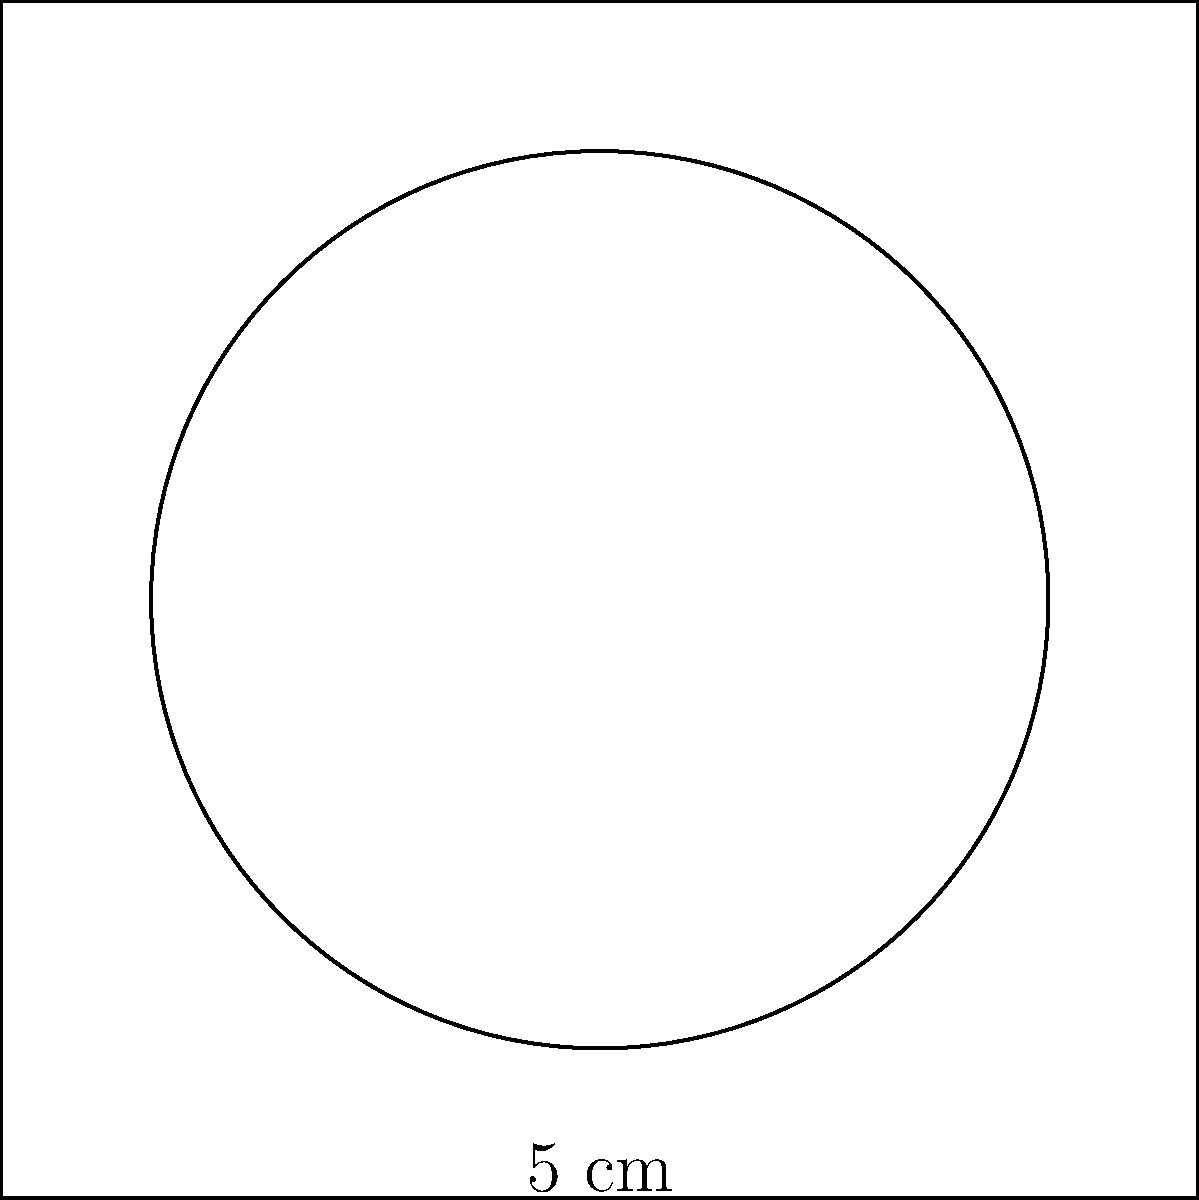A customer accidentally spilled coffee on your new tablecloth, leaving a circular stain. You measure the diameter of the stain to be 10 cm. What is the area of the coffee stain in square centimeters? Round your answer to the nearest whole number. To find the area of the circular coffee stain, we'll follow these steps:

1) First, recall the formula for the area of a circle:
   $A = \pi r^2$, where $A$ is the area and $r$ is the radius.

2) We're given the diameter, which is 10 cm. The radius is half of the diameter:
   $r = 10 \text{ cm} \div 2 = 5 \text{ cm}$

3) Now, let's substitute this into our formula:
   $A = \pi (5 \text{ cm})^2$

4) Simplify:
   $A = \pi \cdot 25 \text{ cm}^2$

5) Use 3.14 as an approximation for $\pi$:
   $A \approx 3.14 \cdot 25 \text{ cm}^2 = 78.5 \text{ cm}^2$

6) Rounding to the nearest whole number:
   $A \approx 79 \text{ cm}^2$
Answer: 79 cm² 